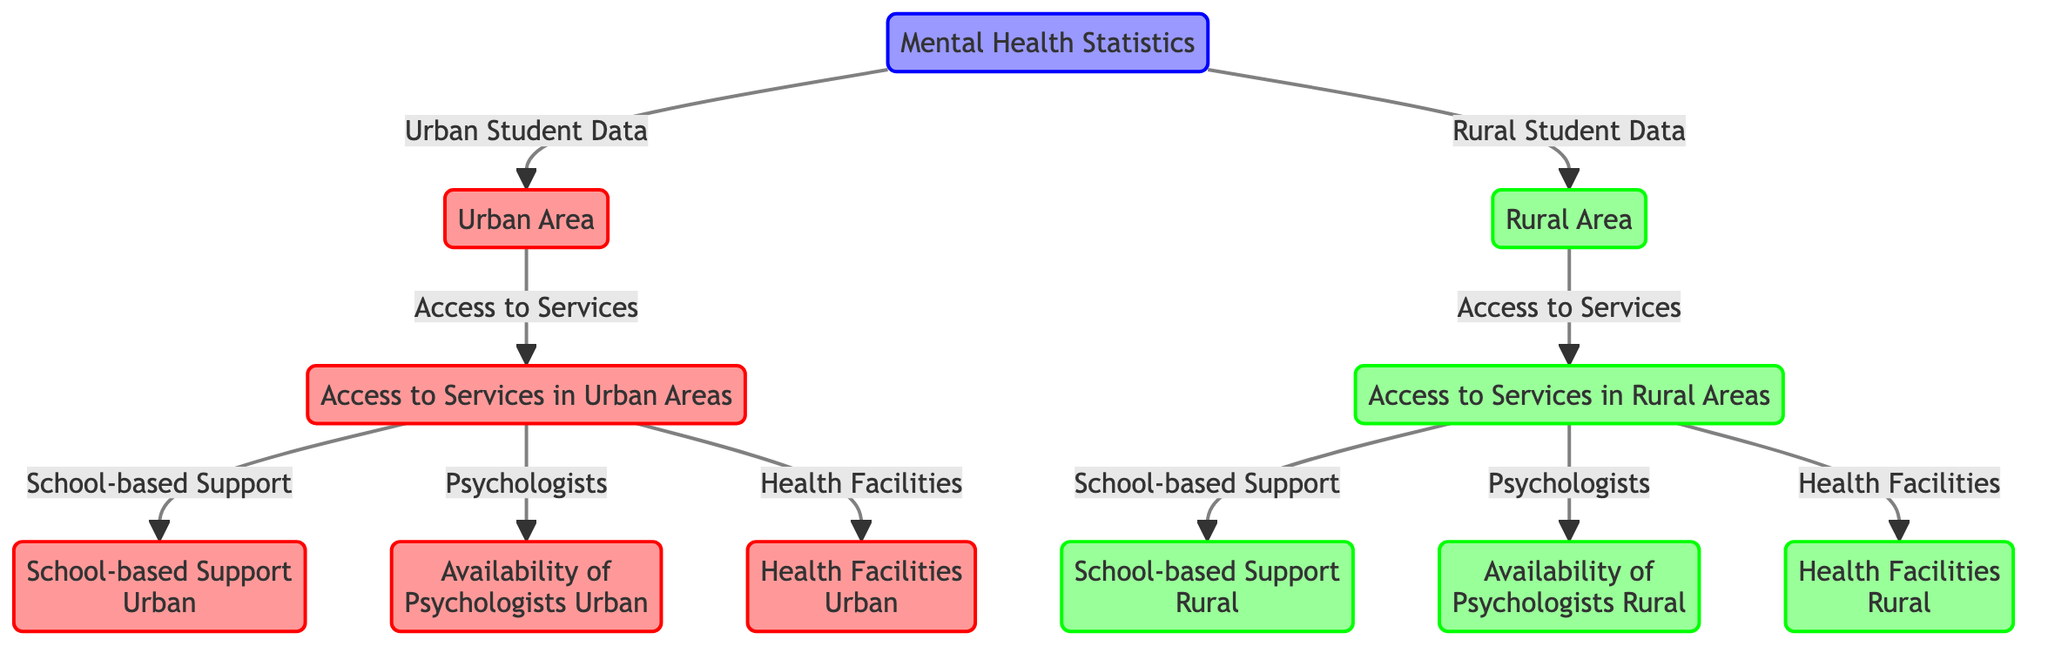What are the three types of access to services represented in urban areas? The diagram shows three types of access to services in urban areas: School-based Support, Psychologists, and Health Facilities. This can be identified by looking at the node labeled "Access to Services in Urban Areas," which connects to the three services listed.
Answer: School-based Support, Psychologists, Health Facilities How many main nodes are there for mental health statistics? The diagram has three main categories: Urban Area, Rural Area, and Mental Health Statistics. These are the primary nodes linked to the main Mental Health Statistics node.
Answer: Three Which area has the label "Availability of Psychologists"? The diagram indicates "Availability of Psychologists" under the Urban Area branch, specifically linked to the "Access to Services in Urban Areas." Moving from the Mental Health Statistics node to the Urban Area and subsequently to its respective access, one can see this label directly.
Answer: Urban Area What is the color coding for rural class nodes? The color coding for rural class nodes is a light greenish shade. By inspecting the diagram, all the nodes associated with rural areas are colored in this specific tone.
Answer: Light green Compare the number of services available in urban vs. rural areas. In the diagram, urban areas show three access service nodes (School-based Support, Psychologists, Health Facilities), while rural areas show the same three nodes under "Access to Services in Rural Areas," suggesting equal representation in this context. Therefore, the number of services available is the same.
Answer: Same Which area has fewer access points for services? Based on the diagram, neither area has fewer access points since both urban and rural areas display the same three types of access points for services. The connections from both urban and rural nodes lead to three services each, indicating equal access.
Answer: Neither What is the overall structure of the diagram focusing on mental health? The overall structure connects the main element, Mental Health Statistics, to two branches representing Urban and Rural Areas, each of which further connects to Access to Services. Continuing from there, further branches lead to specific types of services needed for mental health support. This layered structure displays the relationship between the broader category and specific access points effectively.
Answer: Multi-layered What distinguishes urban access to services from rural access? Although both urban and rural areas provide the same types of access to services (School-based Support, Psychologists, Health Facilities), the distinction lies in the context of urban vs. rural as the service accessibility may differ in implementation and availability, but the diagram does not provide specific details on that distinction. Nonetheless, the labels in different colors signify the management of urban and rural services distinctly, and how they are named.
Answer: Context of implementation 